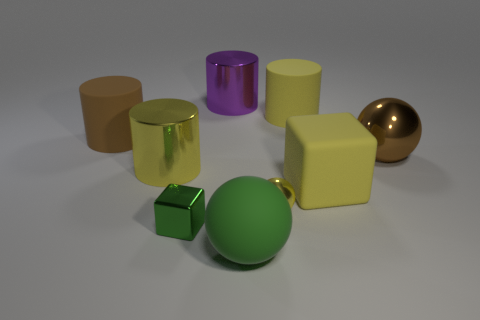There is a large shiny object that is behind the big brown cylinder; what is its shape?
Give a very brief answer. Cylinder. How many objects are large yellow metal cylinders or large yellow cylinders to the left of the small cube?
Provide a short and direct response. 1. Does the big purple object have the same material as the large brown cylinder?
Your response must be concise. No. Are there the same number of large yellow cubes that are to the left of the big rubber ball and large matte things to the right of the purple shiny cylinder?
Give a very brief answer. No. There is a green metallic object; what number of tiny balls are in front of it?
Your answer should be compact. 0. What number of things are big yellow matte blocks or tiny yellow shiny spheres?
Your answer should be very brief. 2. What number of yellow matte things have the same size as the green metal block?
Your answer should be compact. 0. What shape is the big metallic thing behind the large shiny thing on the right side of the rubber ball?
Provide a succinct answer. Cylinder. Are there fewer large purple metal objects than shiny balls?
Your response must be concise. Yes. There is a large matte object in front of the tiny green thing; what color is it?
Your answer should be very brief. Green. 